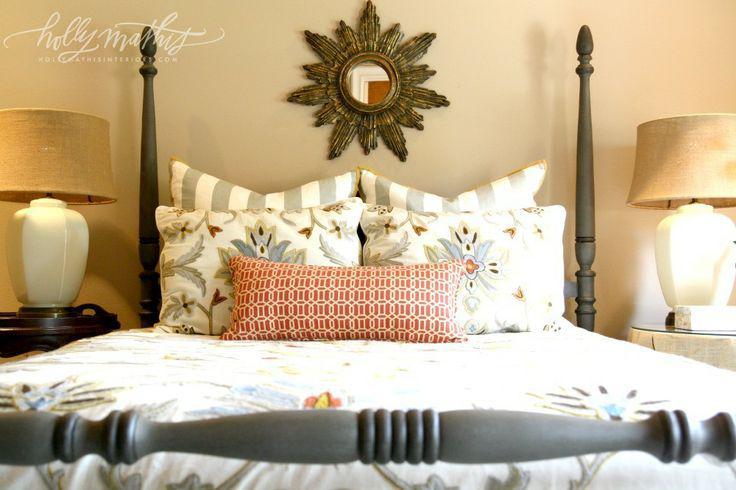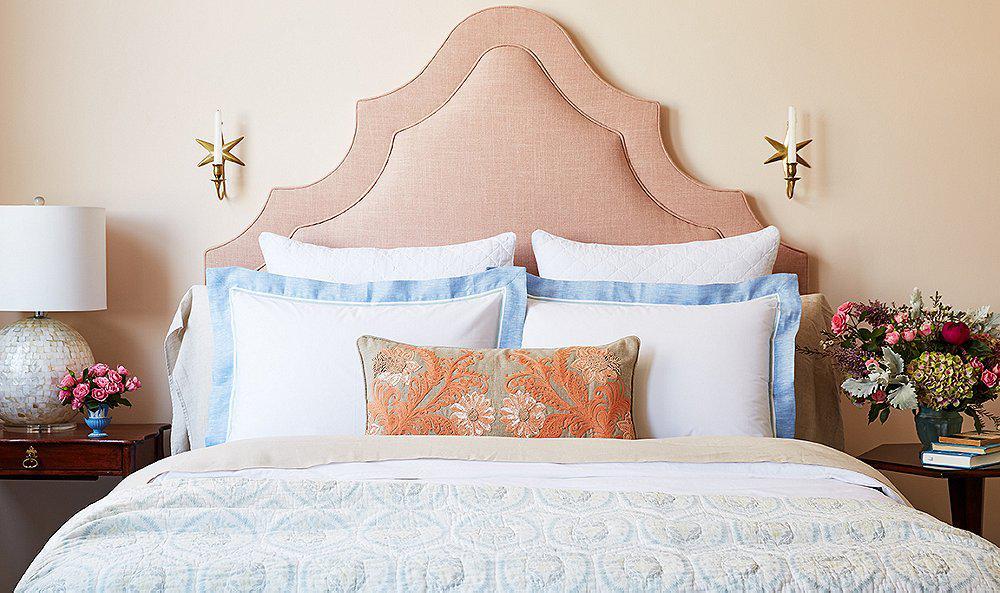The first image is the image on the left, the second image is the image on the right. Given the left and right images, does the statement "The right image shows a narrow pillow centered in front of side-by-side pillows on a bed with an upholstered arch-topped headboard." hold true? Answer yes or no. Yes. The first image is the image on the left, the second image is the image on the right. Considering the images on both sides, is "In at least one image there is a bed with a light colored comforter and an arched triangle like bed board." valid? Answer yes or no. Yes. 